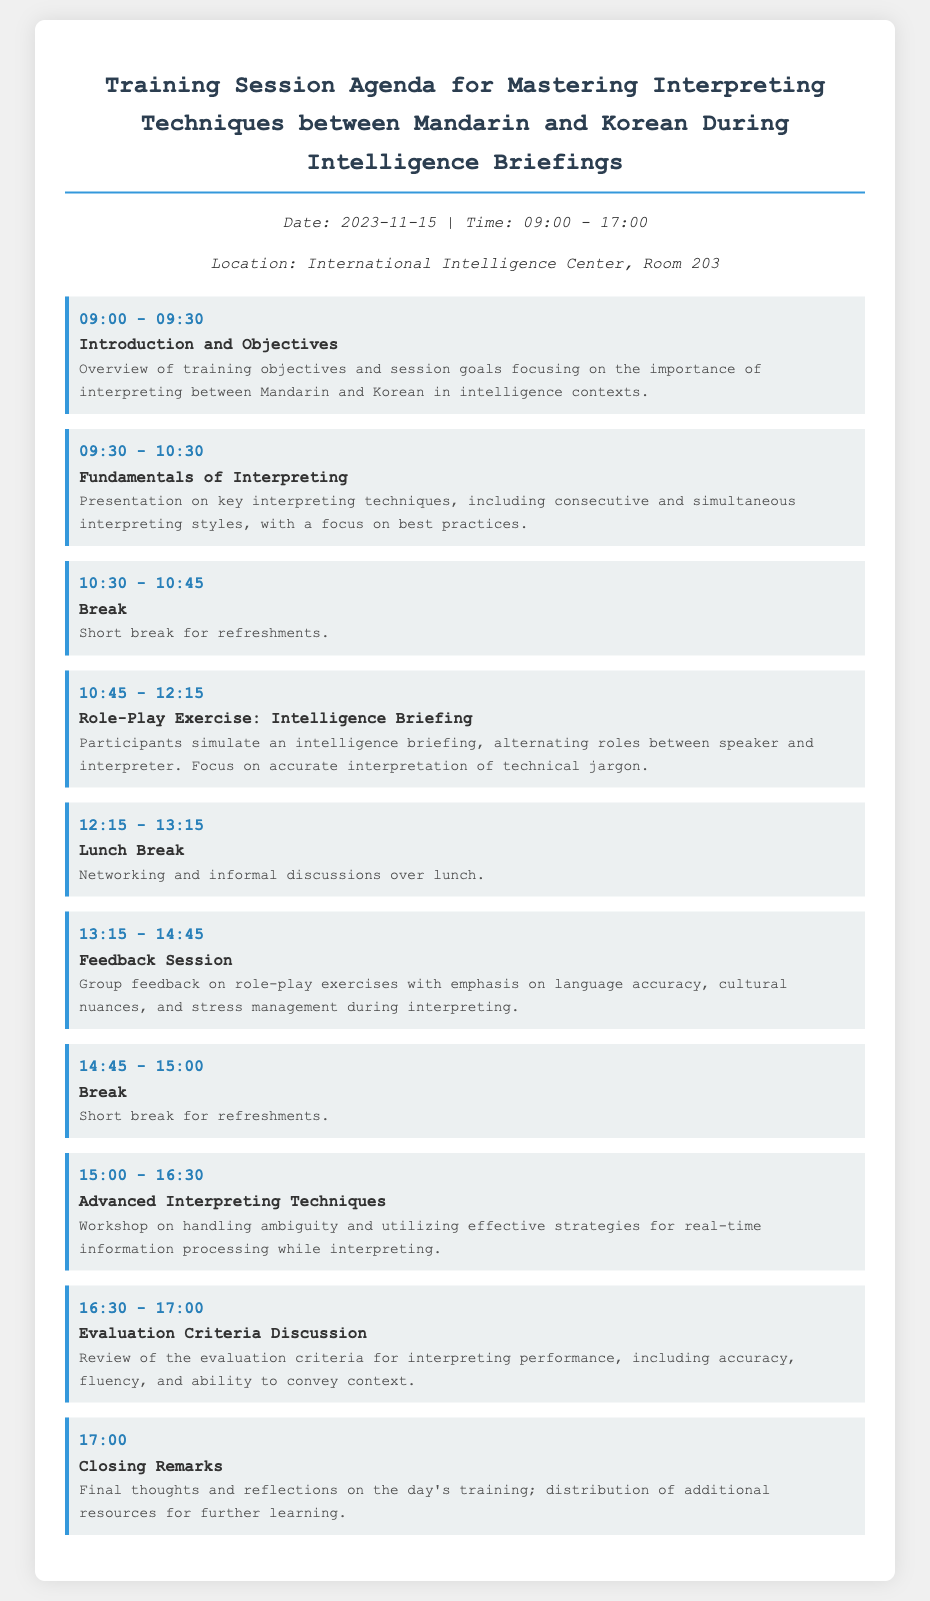What is the date of the training session? The date is explicitly mentioned in the document under the meta-info section.
Answer: 2023-11-15 What is the location of the training session? The location is provided in the meta-info section of the document.
Answer: International Intelligence Center, Room 203 What time does the training session start? The start time is indicated in the meta-info section.
Answer: 09:00 How long is the lunch break? The duration of the lunch break can be inferred from the scheduled time listed in the agenda.
Answer: 1 hour What activity follows the break at 10:30? The schedule provides a clear order of activities following the break.
Answer: Role-Play Exercise: Intelligence Briefing What is the focus of the feedback session? The description outlines the main topics discussed during the feedback session.
Answer: Language accuracy, cultural nuances, and stress management What is the final activity of the day? The last item in the schedule indicates the concluding activity.
Answer: Closing Remarks What is one of the topics covered in the Advanced Interpreting Techniques workshop? The description of the workshop provides insight on the key focus areas.
Answer: Handling ambiguity What is the duration of the Fundamentals of Interpreting session? The length of this session is specified in the agenda.
Answer: 1 hour What is provided at the end of the Closing Remarks? The last part of this section mentions what participants will receive.
Answer: Additional resources for further learning 